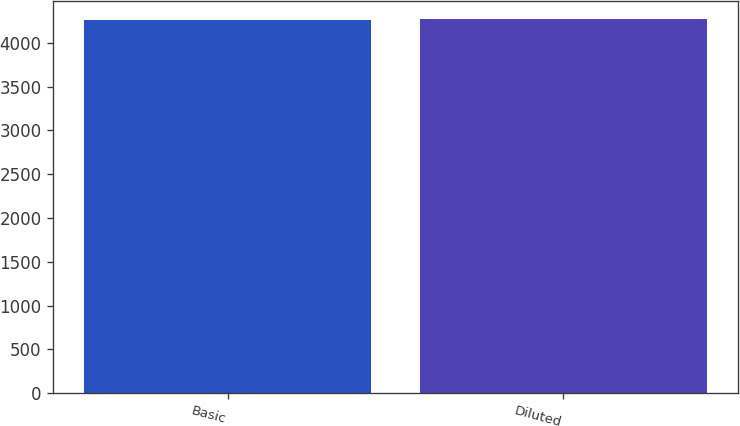Convert chart to OTSL. <chart><loc_0><loc_0><loc_500><loc_500><bar_chart><fcel>Basic<fcel>Diluted<nl><fcel>4267<fcel>4270<nl></chart> 